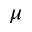<formula> <loc_0><loc_0><loc_500><loc_500>\mu</formula> 